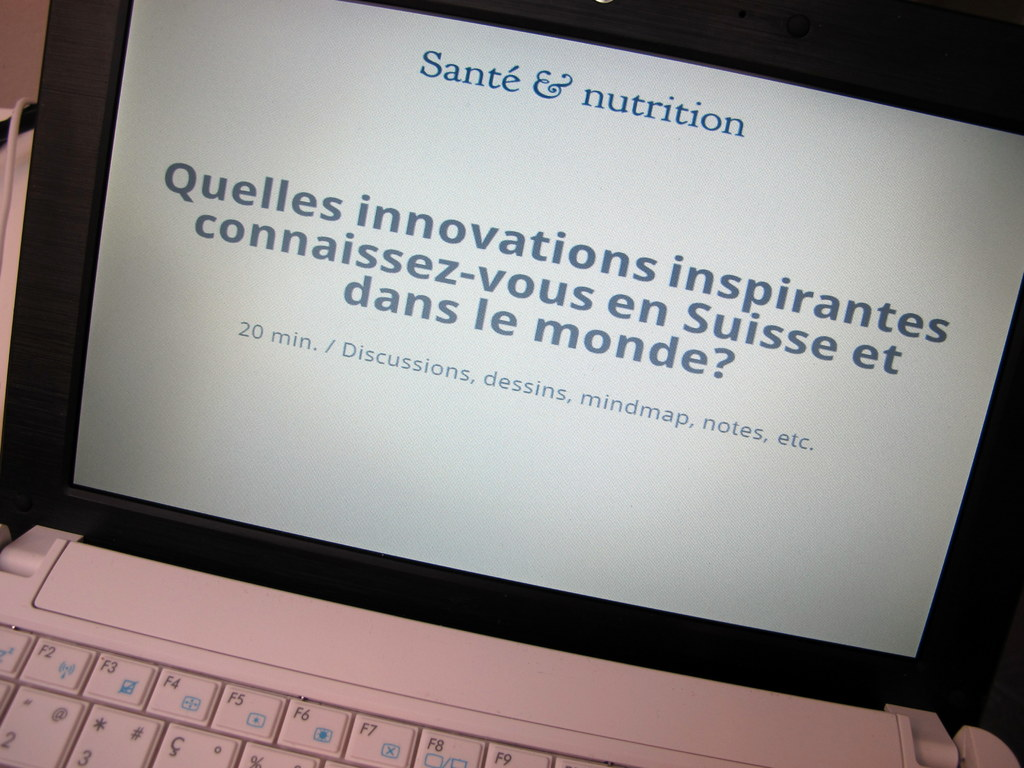What are some potential topics that might be discussed under the theme of 'Health & Nutrition' based on the slide? Potential topics for discussion could include recent breakthroughs in nutritional science, innovative health-focused foods or supplements, technology advancements in health care, and global initiatives aiming to improve public health through better nutrition. Participants might also explore how these innovations impact societal health outcomes or discuss barriers to accessing nutrition innovations. 